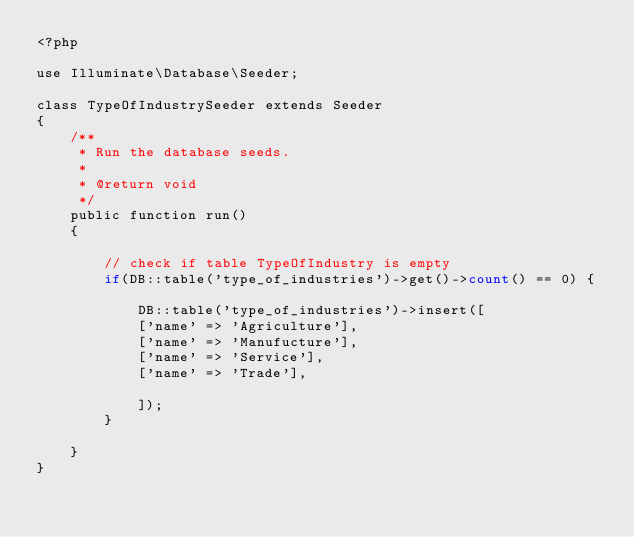Convert code to text. <code><loc_0><loc_0><loc_500><loc_500><_PHP_><?php

use Illuminate\Database\Seeder;

class TypeOfIndustrySeeder extends Seeder
{
    /**
     * Run the database seeds.
     *
     * @return void
     */
    public function run()
    {

        // check if table TypeOfIndustry is empty
        if(DB::table('type_of_industries')->get()->count() == 0) {

            DB::table('type_of_industries')->insert([
            ['name' => 'Agriculture'],
            ['name' => 'Manufucture'],
            ['name' => 'Service'],
            ['name' => 'Trade'],

            ]);
        }

    }
}
</code> 